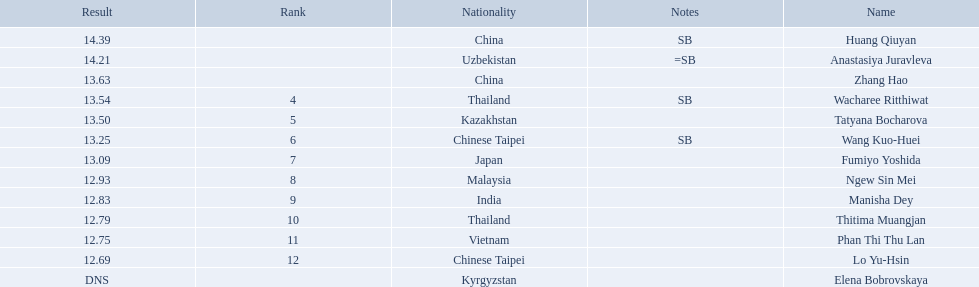What was the point difference between the 1st place contestant and the 12th place contestant? 1.7. 